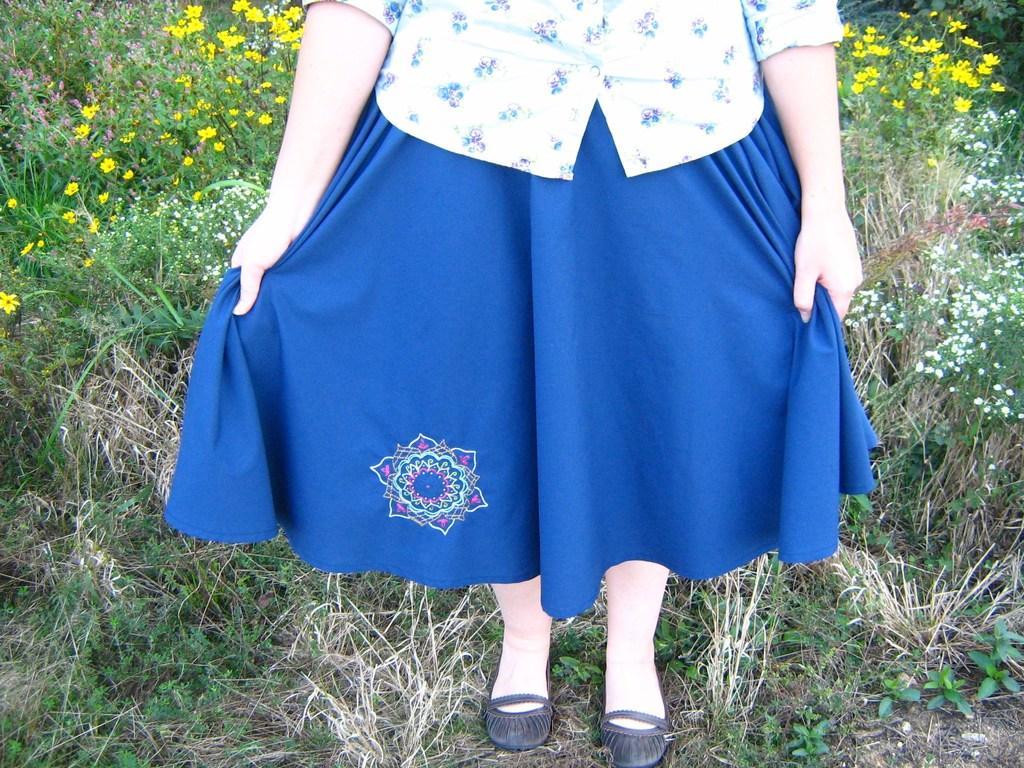Please provide a concise description of this image. In this image we can see a person standing on the grass on the ground. In the background there are plants with flowers. 